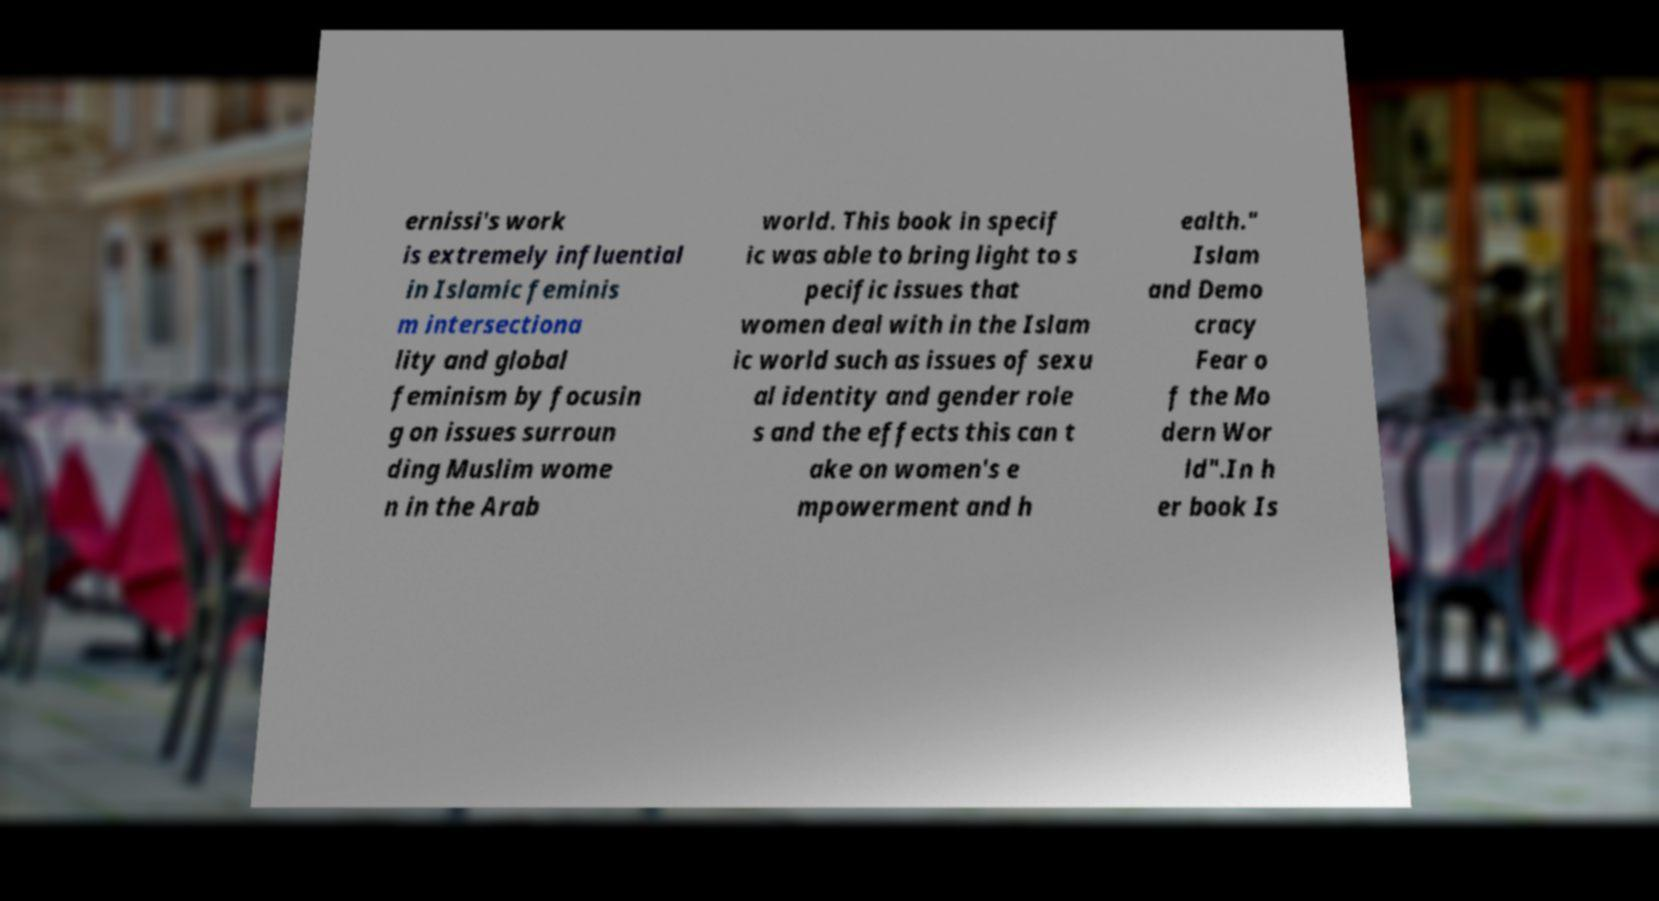There's text embedded in this image that I need extracted. Can you transcribe it verbatim? ernissi's work is extremely influential in Islamic feminis m intersectiona lity and global feminism by focusin g on issues surroun ding Muslim wome n in the Arab world. This book in specif ic was able to bring light to s pecific issues that women deal with in the Islam ic world such as issues of sexu al identity and gender role s and the effects this can t ake on women's e mpowerment and h ealth." Islam and Demo cracy Fear o f the Mo dern Wor ld".In h er book Is 